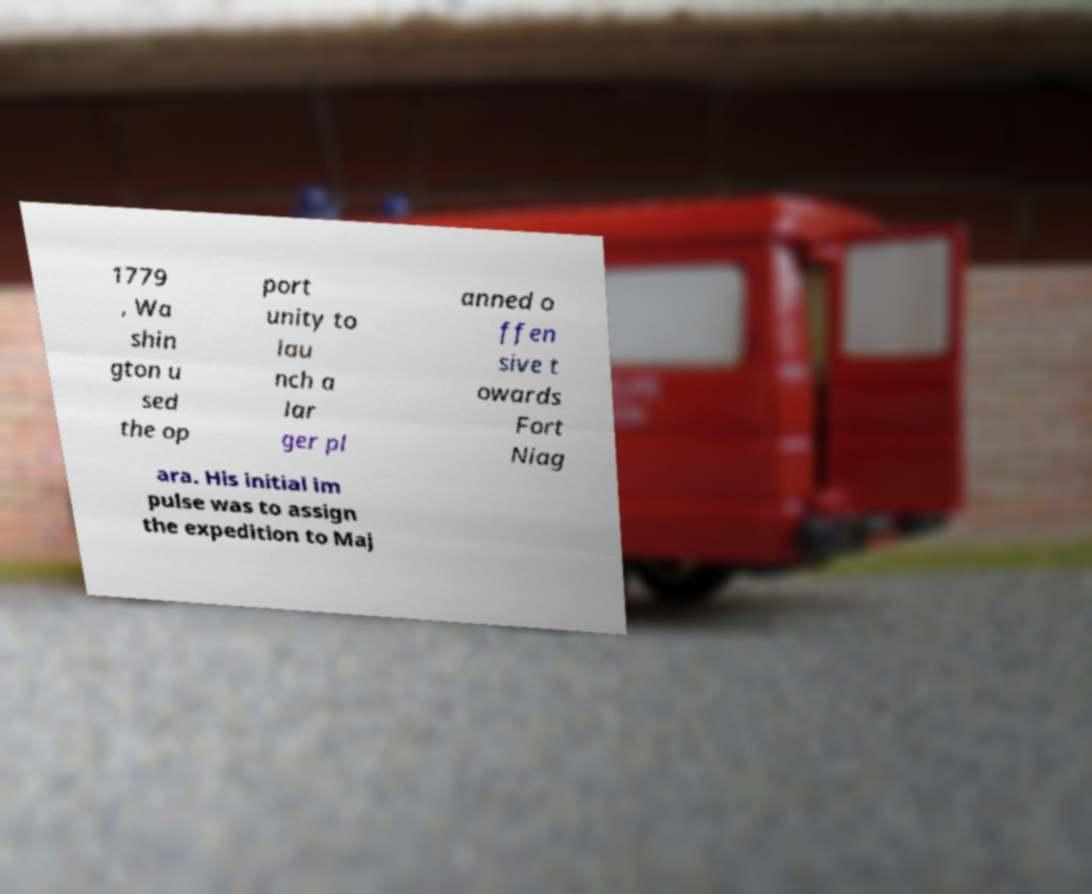What messages or text are displayed in this image? I need them in a readable, typed format. 1779 , Wa shin gton u sed the op port unity to lau nch a lar ger pl anned o ffen sive t owards Fort Niag ara. His initial im pulse was to assign the expedition to Maj 